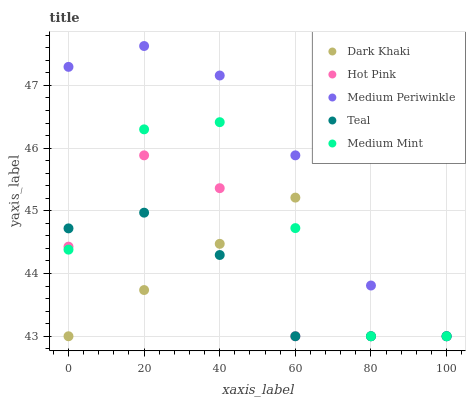Does Teal have the minimum area under the curve?
Answer yes or no. Yes. Does Medium Periwinkle have the maximum area under the curve?
Answer yes or no. Yes. Does Medium Mint have the minimum area under the curve?
Answer yes or no. No. Does Medium Mint have the maximum area under the curve?
Answer yes or no. No. Is Dark Khaki the smoothest?
Answer yes or no. Yes. Is Hot Pink the roughest?
Answer yes or no. Yes. Is Medium Mint the smoothest?
Answer yes or no. No. Is Medium Mint the roughest?
Answer yes or no. No. Does Dark Khaki have the lowest value?
Answer yes or no. Yes. Does Medium Periwinkle have the highest value?
Answer yes or no. Yes. Does Medium Mint have the highest value?
Answer yes or no. No. Does Medium Mint intersect Teal?
Answer yes or no. Yes. Is Medium Mint less than Teal?
Answer yes or no. No. Is Medium Mint greater than Teal?
Answer yes or no. No. 